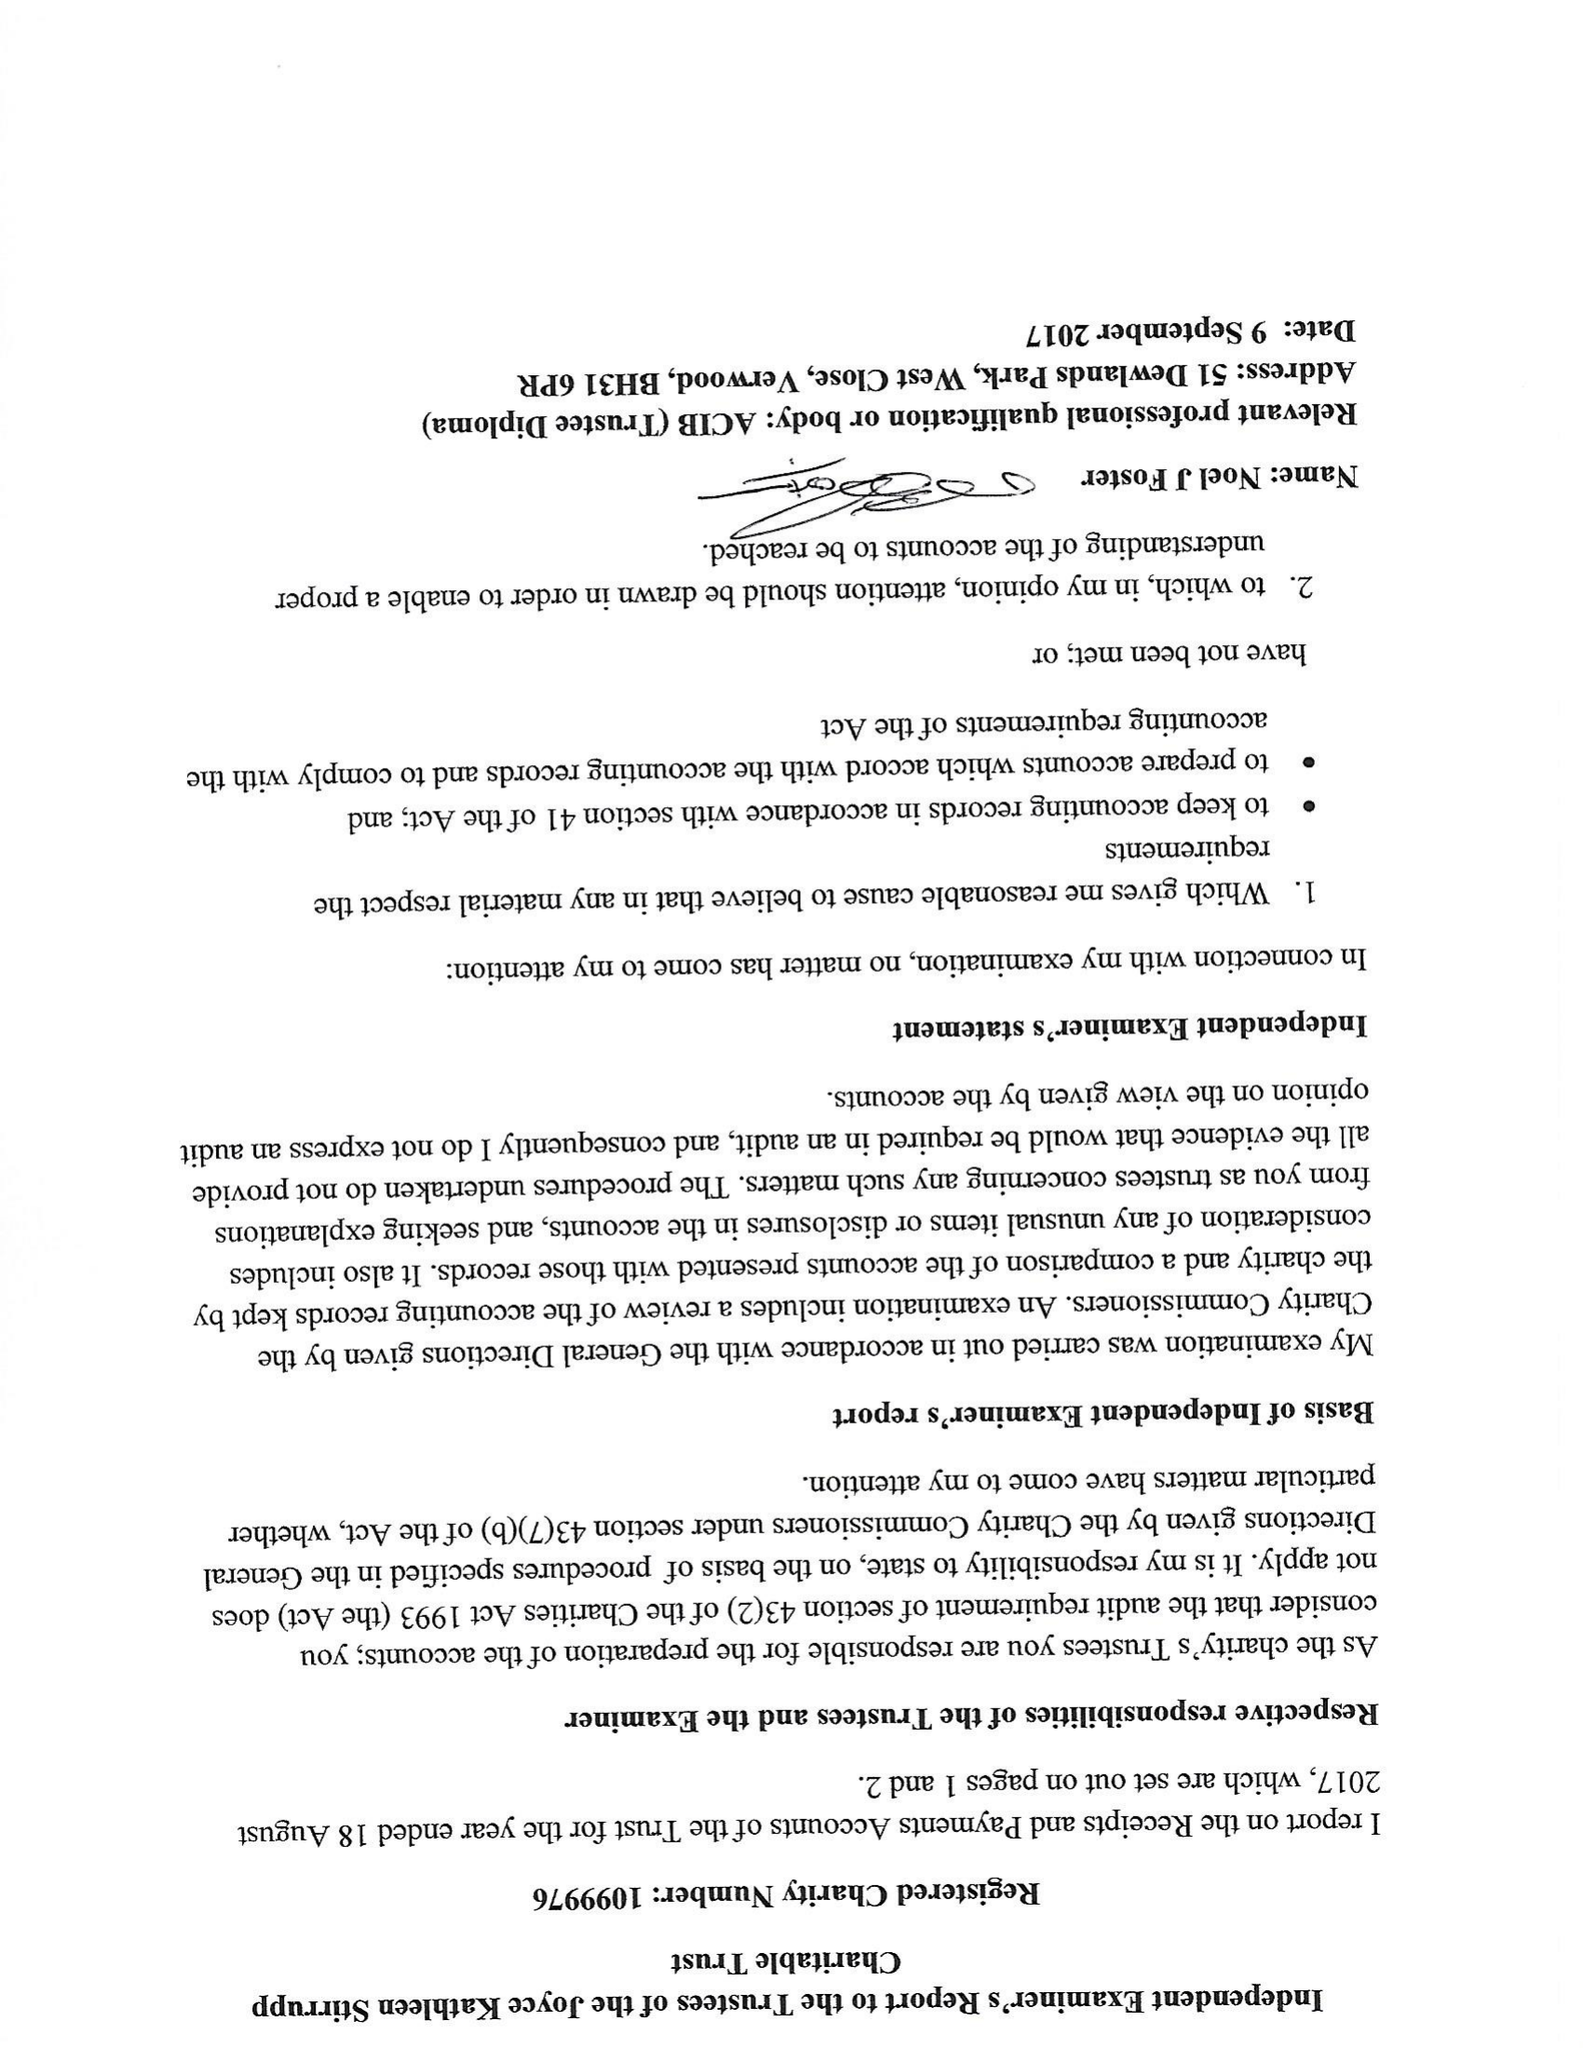What is the value for the income_annually_in_british_pounds?
Answer the question using a single word or phrase. 142991.00 